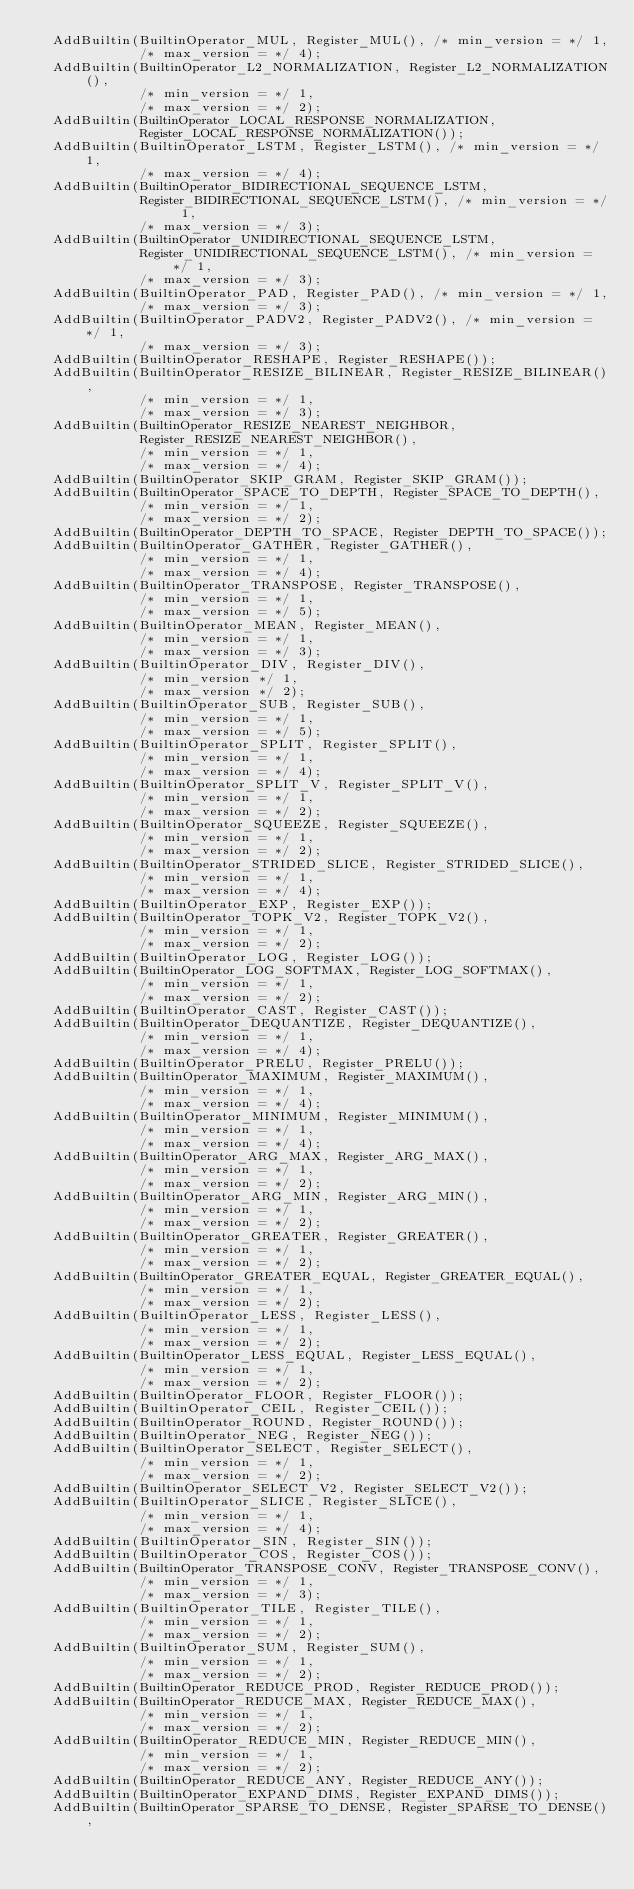<code> <loc_0><loc_0><loc_500><loc_500><_C++_>  AddBuiltin(BuiltinOperator_MUL, Register_MUL(), /* min_version = */ 1,
             /* max_version = */ 4);
  AddBuiltin(BuiltinOperator_L2_NORMALIZATION, Register_L2_NORMALIZATION(),
             /* min_version = */ 1,
             /* max_version = */ 2);
  AddBuiltin(BuiltinOperator_LOCAL_RESPONSE_NORMALIZATION,
             Register_LOCAL_RESPONSE_NORMALIZATION());
  AddBuiltin(BuiltinOperator_LSTM, Register_LSTM(), /* min_version = */ 1,
             /* max_version = */ 4);
  AddBuiltin(BuiltinOperator_BIDIRECTIONAL_SEQUENCE_LSTM,
             Register_BIDIRECTIONAL_SEQUENCE_LSTM(), /* min_version = */ 1,
             /* max_version = */ 3);
  AddBuiltin(BuiltinOperator_UNIDIRECTIONAL_SEQUENCE_LSTM,
             Register_UNIDIRECTIONAL_SEQUENCE_LSTM(), /* min_version = */ 1,
             /* max_version = */ 3);
  AddBuiltin(BuiltinOperator_PAD, Register_PAD(), /* min_version = */ 1,
             /* max_version = */ 3);
  AddBuiltin(BuiltinOperator_PADV2, Register_PADV2(), /* min_version = */ 1,
             /* max_version = */ 3);
  AddBuiltin(BuiltinOperator_RESHAPE, Register_RESHAPE());
  AddBuiltin(BuiltinOperator_RESIZE_BILINEAR, Register_RESIZE_BILINEAR(),
             /* min_version = */ 1,
             /* max_version = */ 3);
  AddBuiltin(BuiltinOperator_RESIZE_NEAREST_NEIGHBOR,
             Register_RESIZE_NEAREST_NEIGHBOR(),
             /* min_version = */ 1,
             /* max_version = */ 4);
  AddBuiltin(BuiltinOperator_SKIP_GRAM, Register_SKIP_GRAM());
  AddBuiltin(BuiltinOperator_SPACE_TO_DEPTH, Register_SPACE_TO_DEPTH(),
             /* min_version = */ 1,
             /* max_version = */ 2);
  AddBuiltin(BuiltinOperator_DEPTH_TO_SPACE, Register_DEPTH_TO_SPACE());
  AddBuiltin(BuiltinOperator_GATHER, Register_GATHER(),
             /* min_version = */ 1,
             /* max_version = */ 4);
  AddBuiltin(BuiltinOperator_TRANSPOSE, Register_TRANSPOSE(),
             /* min_version = */ 1,
             /* max_version = */ 5);
  AddBuiltin(BuiltinOperator_MEAN, Register_MEAN(),
             /* min_version = */ 1,
             /* max_version = */ 3);
  AddBuiltin(BuiltinOperator_DIV, Register_DIV(),
             /* min_version */ 1,
             /* max_version */ 2);
  AddBuiltin(BuiltinOperator_SUB, Register_SUB(),
             /* min_version = */ 1,
             /* max_version = */ 5);
  AddBuiltin(BuiltinOperator_SPLIT, Register_SPLIT(),
             /* min_version = */ 1,
             /* max_version = */ 4);
  AddBuiltin(BuiltinOperator_SPLIT_V, Register_SPLIT_V(),
             /* min_version = */ 1,
             /* max_version = */ 2);
  AddBuiltin(BuiltinOperator_SQUEEZE, Register_SQUEEZE(),
             /* min_version = */ 1,
             /* max_version = */ 2);
  AddBuiltin(BuiltinOperator_STRIDED_SLICE, Register_STRIDED_SLICE(),
             /* min_version = */ 1,
             /* max_version = */ 4);
  AddBuiltin(BuiltinOperator_EXP, Register_EXP());
  AddBuiltin(BuiltinOperator_TOPK_V2, Register_TOPK_V2(),
             /* min_version = */ 1,
             /* max_version = */ 2);
  AddBuiltin(BuiltinOperator_LOG, Register_LOG());
  AddBuiltin(BuiltinOperator_LOG_SOFTMAX, Register_LOG_SOFTMAX(),
             /* min_version = */ 1,
             /* max_version = */ 2);
  AddBuiltin(BuiltinOperator_CAST, Register_CAST());
  AddBuiltin(BuiltinOperator_DEQUANTIZE, Register_DEQUANTIZE(),
             /* min_version = */ 1,
             /* max_version = */ 4);
  AddBuiltin(BuiltinOperator_PRELU, Register_PRELU());
  AddBuiltin(BuiltinOperator_MAXIMUM, Register_MAXIMUM(),
             /* min_version = */ 1,
             /* max_version = */ 4);
  AddBuiltin(BuiltinOperator_MINIMUM, Register_MINIMUM(),
             /* min_version = */ 1,
             /* max_version = */ 4);
  AddBuiltin(BuiltinOperator_ARG_MAX, Register_ARG_MAX(),
             /* min_version = */ 1,
             /* max_version = */ 2);
  AddBuiltin(BuiltinOperator_ARG_MIN, Register_ARG_MIN(),
             /* min_version = */ 1,
             /* max_version = */ 2);
  AddBuiltin(BuiltinOperator_GREATER, Register_GREATER(),
             /* min_version = */ 1,
             /* max_version = */ 2);
  AddBuiltin(BuiltinOperator_GREATER_EQUAL, Register_GREATER_EQUAL(),
             /* min_version = */ 1,
             /* max_version = */ 2);
  AddBuiltin(BuiltinOperator_LESS, Register_LESS(),
             /* min_version = */ 1,
             /* max_version = */ 2);
  AddBuiltin(BuiltinOperator_LESS_EQUAL, Register_LESS_EQUAL(),
             /* min_version = */ 1,
             /* max_version = */ 2);
  AddBuiltin(BuiltinOperator_FLOOR, Register_FLOOR());
  AddBuiltin(BuiltinOperator_CEIL, Register_CEIL());
  AddBuiltin(BuiltinOperator_ROUND, Register_ROUND());
  AddBuiltin(BuiltinOperator_NEG, Register_NEG());
  AddBuiltin(BuiltinOperator_SELECT, Register_SELECT(),
             /* min_version = */ 1,
             /* max_version = */ 2);
  AddBuiltin(BuiltinOperator_SELECT_V2, Register_SELECT_V2());
  AddBuiltin(BuiltinOperator_SLICE, Register_SLICE(),
             /* min_version = */ 1,
             /* max_version = */ 4);
  AddBuiltin(BuiltinOperator_SIN, Register_SIN());
  AddBuiltin(BuiltinOperator_COS, Register_COS());
  AddBuiltin(BuiltinOperator_TRANSPOSE_CONV, Register_TRANSPOSE_CONV(),
             /* min_version = */ 1,
             /* max_version = */ 3);
  AddBuiltin(BuiltinOperator_TILE, Register_TILE(),
             /* min_version = */ 1,
             /* max_version = */ 2);
  AddBuiltin(BuiltinOperator_SUM, Register_SUM(),
             /* min_version = */ 1,
             /* max_version = */ 2);
  AddBuiltin(BuiltinOperator_REDUCE_PROD, Register_REDUCE_PROD());
  AddBuiltin(BuiltinOperator_REDUCE_MAX, Register_REDUCE_MAX(),
             /* min_version = */ 1,
             /* max_version = */ 2);
  AddBuiltin(BuiltinOperator_REDUCE_MIN, Register_REDUCE_MIN(),
             /* min_version = */ 1,
             /* max_version = */ 2);
  AddBuiltin(BuiltinOperator_REDUCE_ANY, Register_REDUCE_ANY());
  AddBuiltin(BuiltinOperator_EXPAND_DIMS, Register_EXPAND_DIMS());
  AddBuiltin(BuiltinOperator_SPARSE_TO_DENSE, Register_SPARSE_TO_DENSE(),</code> 